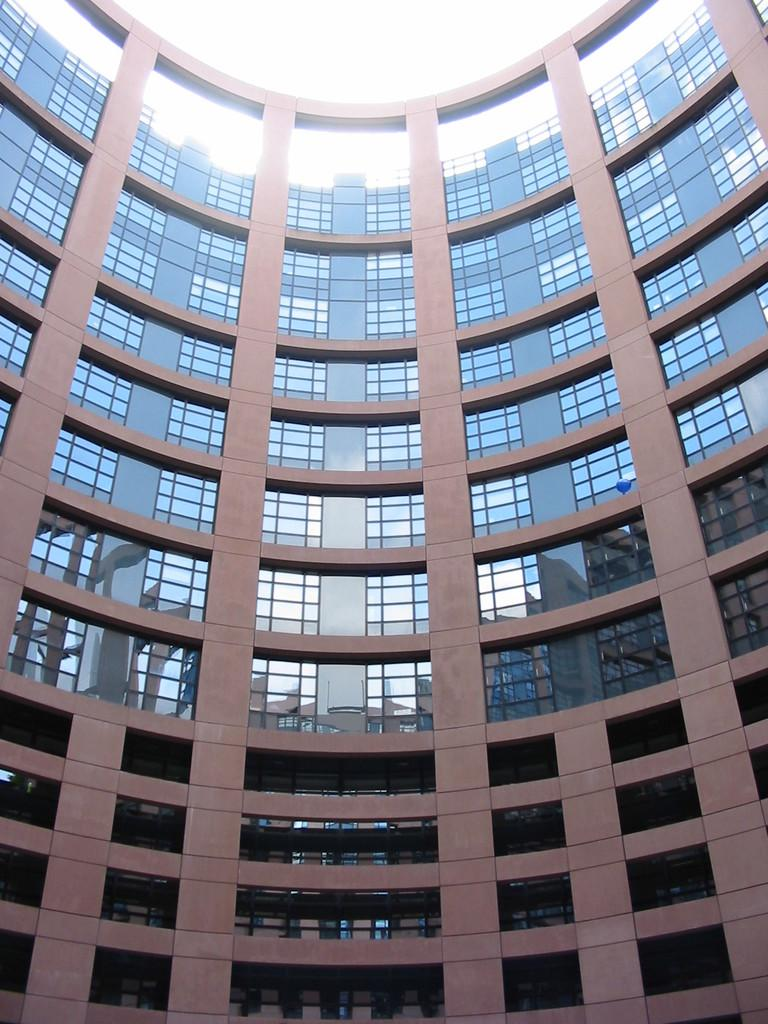What type of structure is present in the image? There is a building in the image. What feature can be observed on the building? The building has glass windows. What can be seen in the background of the image? The sky is visible in the background of the image. Can you read the letter that is being delivered to the building in the image? There is no letter or delivery person present in the image, so it is not possible to read a letter being delivered. 